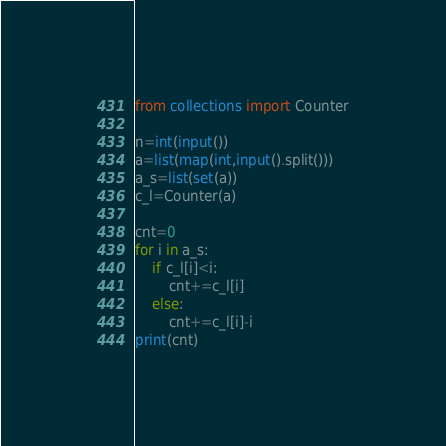Convert code to text. <code><loc_0><loc_0><loc_500><loc_500><_Python_>from collections import Counter

n=int(input())
a=list(map(int,input().split()))
a_s=list(set(a))
c_l=Counter(a)

cnt=0
for i in a_s:
    if c_l[i]<i:
        cnt+=c_l[i]
    else:
        cnt+=c_l[i]-i
print(cnt)</code> 